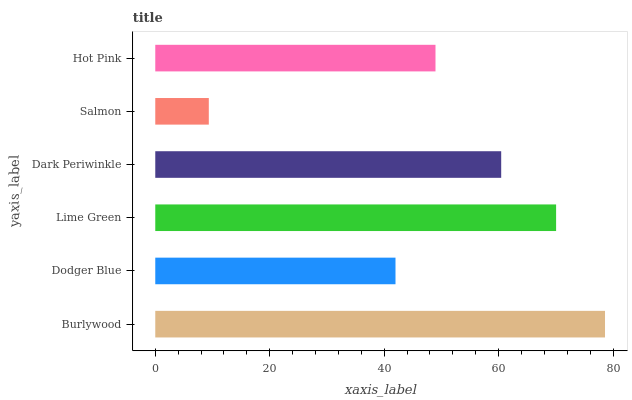Is Salmon the minimum?
Answer yes or no. Yes. Is Burlywood the maximum?
Answer yes or no. Yes. Is Dodger Blue the minimum?
Answer yes or no. No. Is Dodger Blue the maximum?
Answer yes or no. No. Is Burlywood greater than Dodger Blue?
Answer yes or no. Yes. Is Dodger Blue less than Burlywood?
Answer yes or no. Yes. Is Dodger Blue greater than Burlywood?
Answer yes or no. No. Is Burlywood less than Dodger Blue?
Answer yes or no. No. Is Dark Periwinkle the high median?
Answer yes or no. Yes. Is Hot Pink the low median?
Answer yes or no. Yes. Is Lime Green the high median?
Answer yes or no. No. Is Salmon the low median?
Answer yes or no. No. 